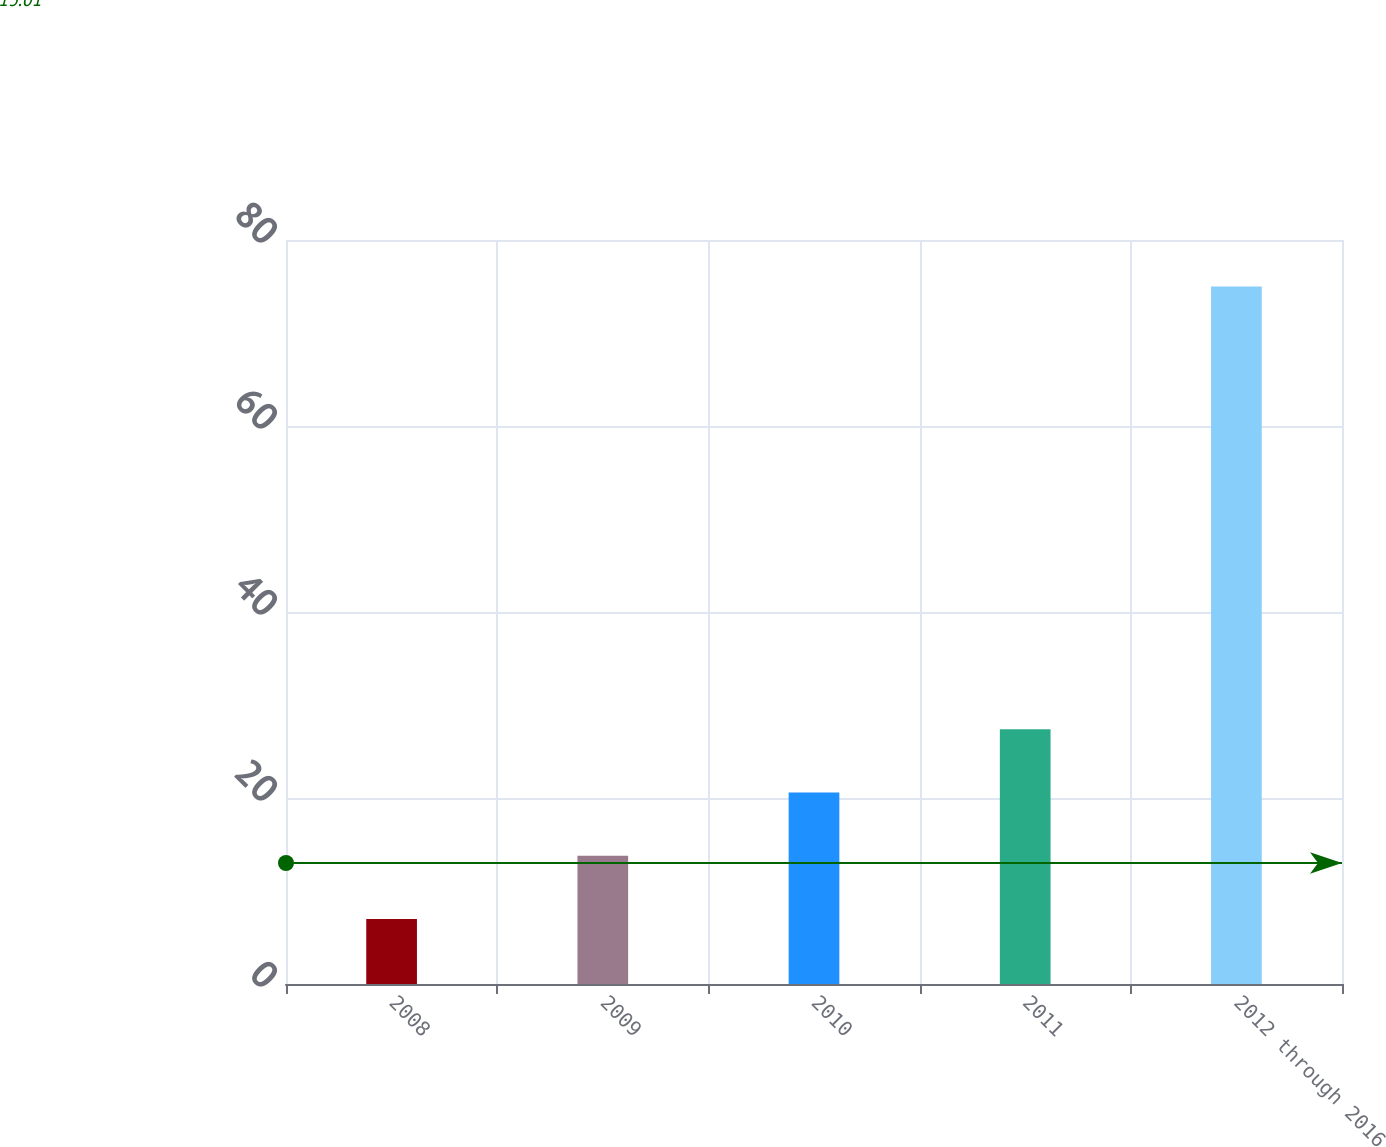Convert chart to OTSL. <chart><loc_0><loc_0><loc_500><loc_500><bar_chart><fcel>2008<fcel>2009<fcel>2010<fcel>2011<fcel>2012 through 2016<nl><fcel>7<fcel>13.8<fcel>20.6<fcel>27.4<fcel>75<nl></chart> 